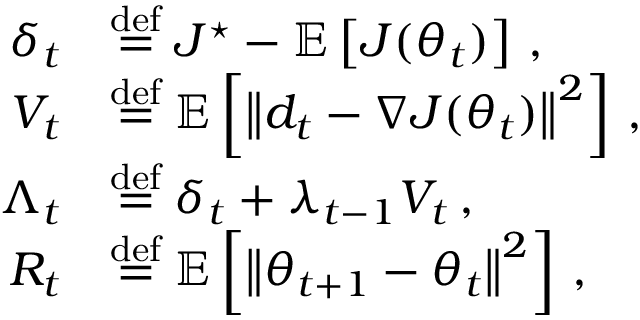<formula> <loc_0><loc_0><loc_500><loc_500>\begin{array} { r l } { \delta _ { t } } & { \stackrel { d e f } { = } J ^ { ^ { * } } - { \mathbb { E } } \left [ J ( \theta _ { t } ) \right ] \, , } \\ { V _ { t } } & { \stackrel { d e f } { = } { \mathbb { E } } \left [ \left \| d _ { t } - \nabla J ( \theta _ { t } ) \right \| ^ { 2 } \right ] \, , } \\ { \Lambda _ { t } } & { \stackrel { d e f } { = } \delta _ { t } + \lambda _ { t - 1 } V _ { t } \, , } \\ { R _ { t } } & { \stackrel { d e f } { = } { \mathbb { E } } \left [ \left \| \theta _ { t + 1 } - \theta _ { t } \right \| ^ { 2 } \right ] \, , } \end{array}</formula> 